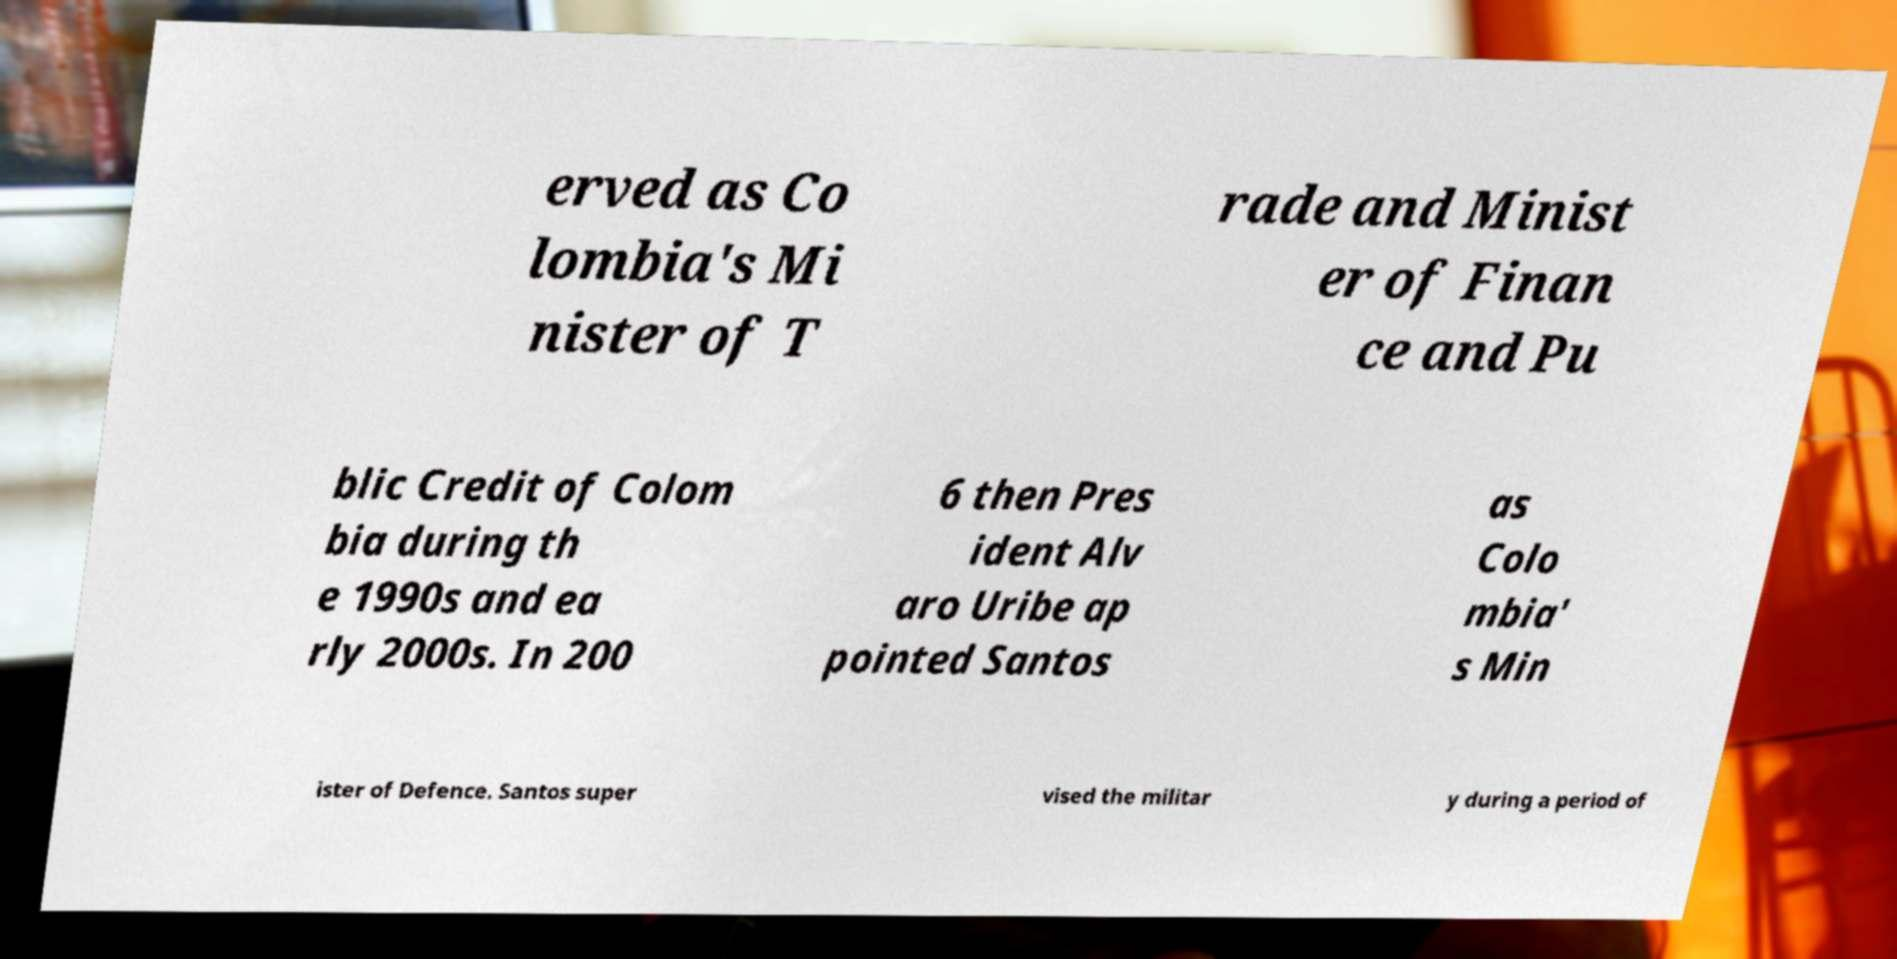Please read and relay the text visible in this image. What does it say? erved as Co lombia's Mi nister of T rade and Minist er of Finan ce and Pu blic Credit of Colom bia during th e 1990s and ea rly 2000s. In 200 6 then Pres ident Alv aro Uribe ap pointed Santos as Colo mbia' s Min ister of Defence. Santos super vised the militar y during a period of 